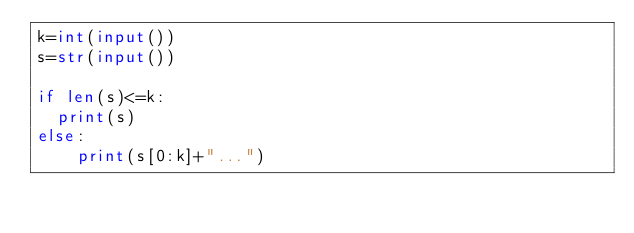Convert code to text. <code><loc_0><loc_0><loc_500><loc_500><_Python_>k=int(input())
s=str(input())

if len(s)<=k:
  print(s)
else:
    print(s[0:k]+"...")</code> 